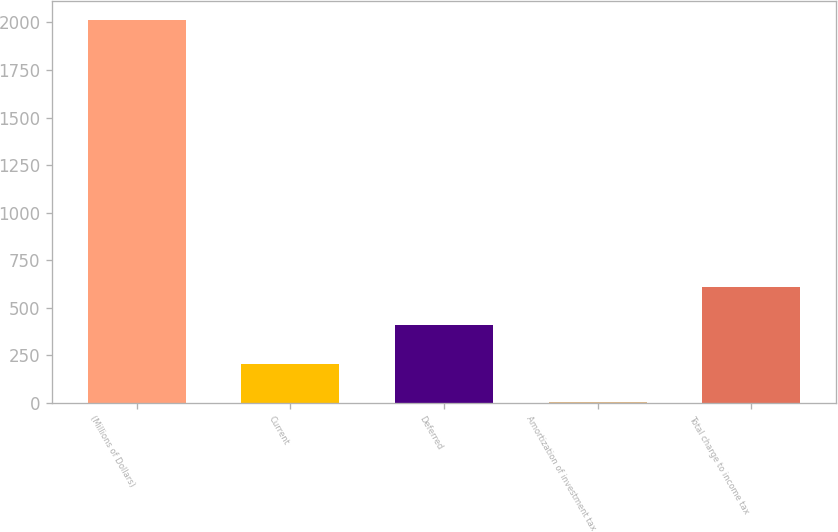<chart> <loc_0><loc_0><loc_500><loc_500><bar_chart><fcel>(Millions of Dollars)<fcel>Current<fcel>Deferred<fcel>Amortization of investment tax<fcel>Total charge to income tax<nl><fcel>2011<fcel>206.5<fcel>407<fcel>6<fcel>607.5<nl></chart> 